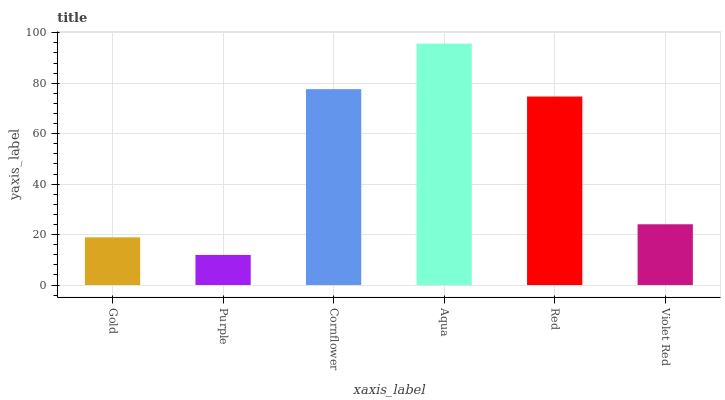Is Cornflower the minimum?
Answer yes or no. No. Is Cornflower the maximum?
Answer yes or no. No. Is Cornflower greater than Purple?
Answer yes or no. Yes. Is Purple less than Cornflower?
Answer yes or no. Yes. Is Purple greater than Cornflower?
Answer yes or no. No. Is Cornflower less than Purple?
Answer yes or no. No. Is Red the high median?
Answer yes or no. Yes. Is Violet Red the low median?
Answer yes or no. Yes. Is Aqua the high median?
Answer yes or no. No. Is Aqua the low median?
Answer yes or no. No. 